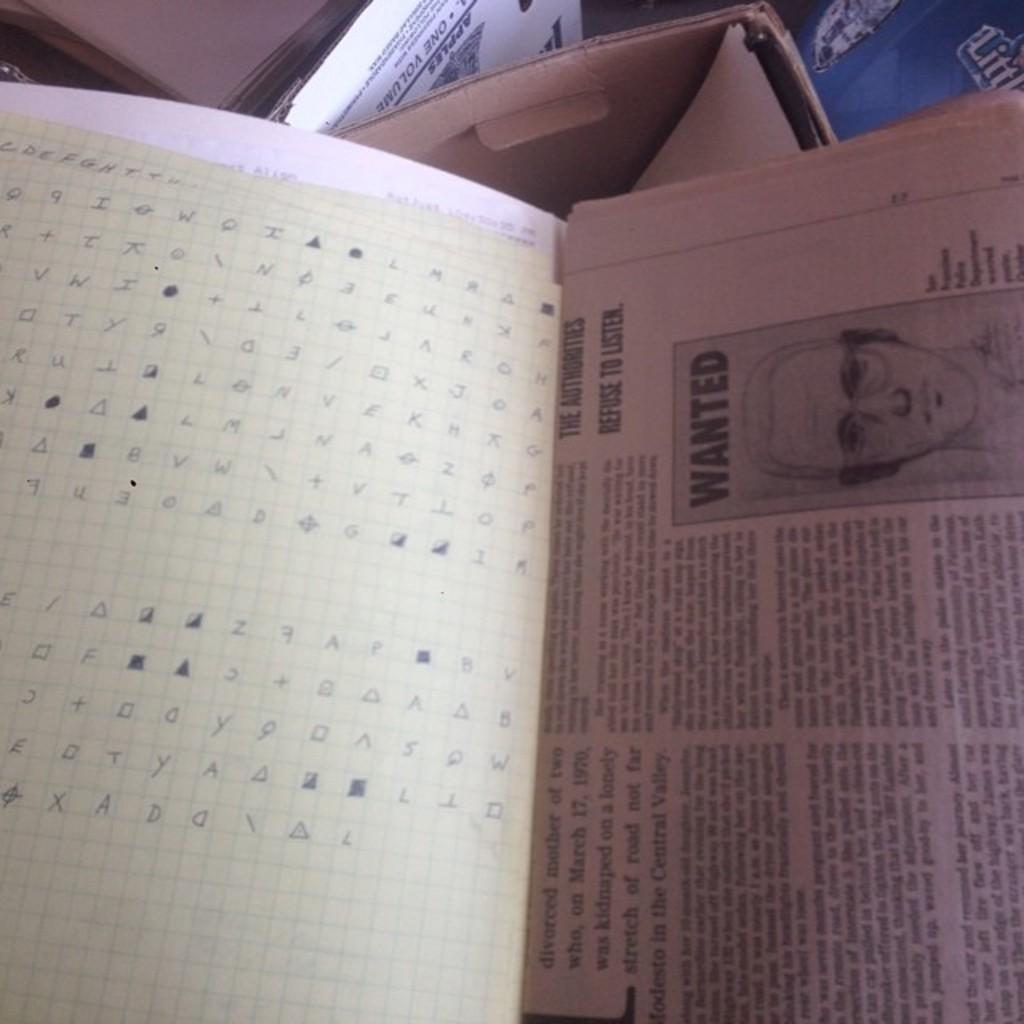<image>
Render a clear and concise summary of the photo. A code is written out on a piece of graph paper, next to a newspaper article with a sketch of a wanted man. 